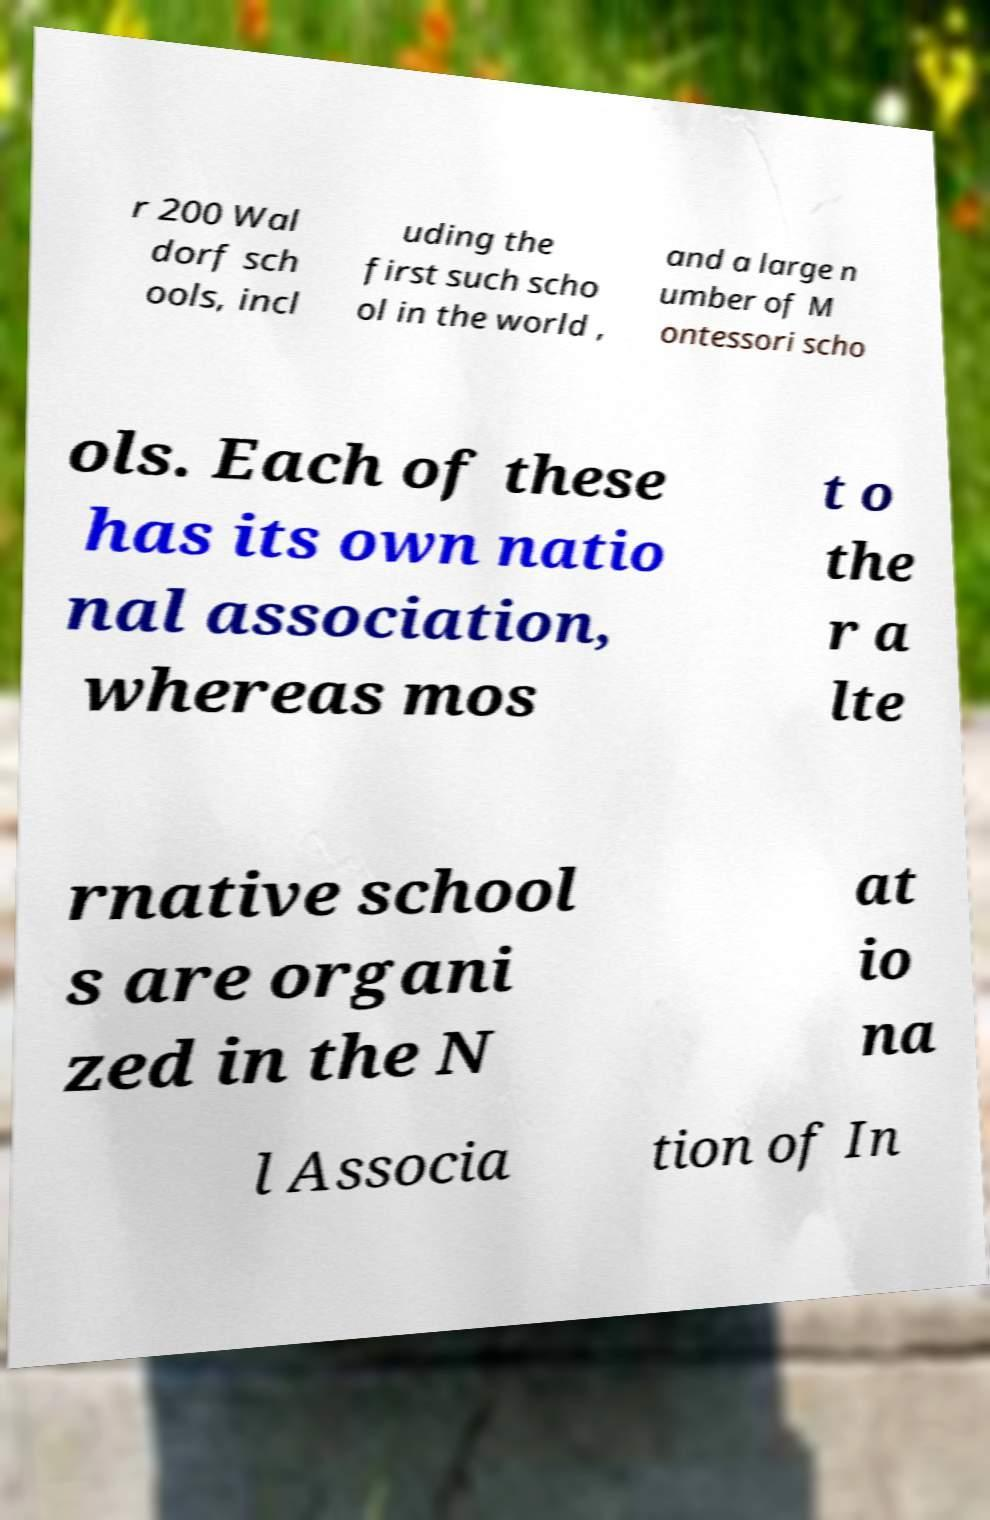Please read and relay the text visible in this image. What does it say? r 200 Wal dorf sch ools, incl uding the first such scho ol in the world , and a large n umber of M ontessori scho ols. Each of these has its own natio nal association, whereas mos t o the r a lte rnative school s are organi zed in the N at io na l Associa tion of In 